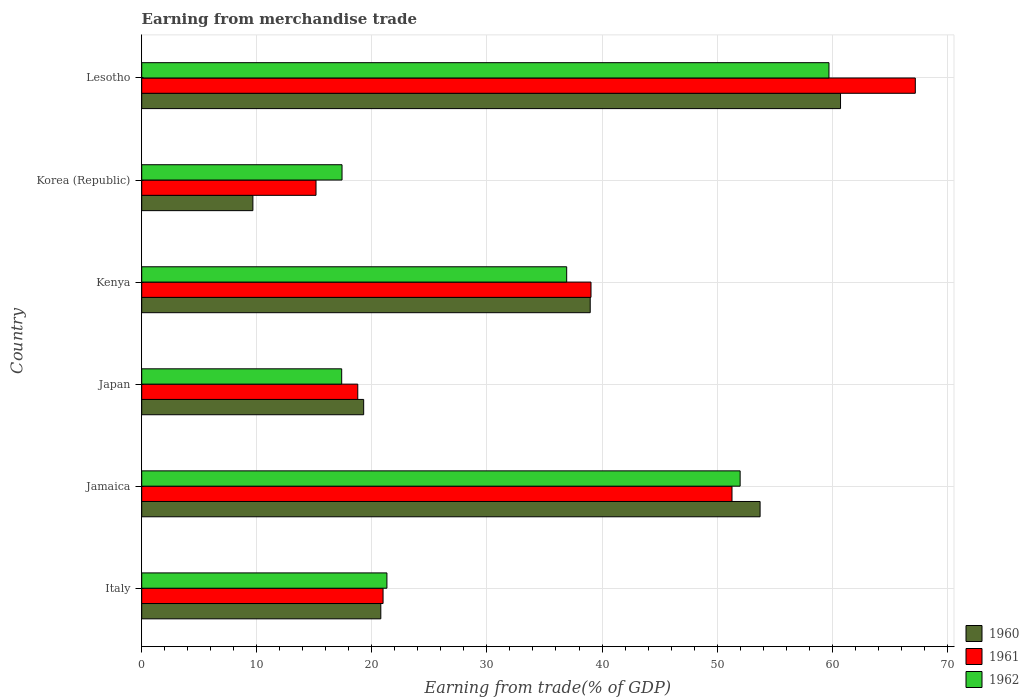How many groups of bars are there?
Give a very brief answer. 6. Are the number of bars per tick equal to the number of legend labels?
Your response must be concise. Yes. Are the number of bars on each tick of the Y-axis equal?
Keep it short and to the point. Yes. What is the label of the 4th group of bars from the top?
Give a very brief answer. Japan. What is the earnings from trade in 1960 in Japan?
Ensure brevity in your answer.  19.29. Across all countries, what is the maximum earnings from trade in 1962?
Provide a succinct answer. 59.72. Across all countries, what is the minimum earnings from trade in 1961?
Your answer should be compact. 15.15. In which country was the earnings from trade in 1961 maximum?
Provide a short and direct response. Lesotho. In which country was the earnings from trade in 1961 minimum?
Keep it short and to the point. Korea (Republic). What is the total earnings from trade in 1962 in the graph?
Offer a very short reply. 204.75. What is the difference between the earnings from trade in 1960 in Korea (Republic) and that in Lesotho?
Your answer should be very brief. -51.07. What is the difference between the earnings from trade in 1960 in Japan and the earnings from trade in 1962 in Jamaica?
Your response must be concise. -32.72. What is the average earnings from trade in 1961 per country?
Provide a succinct answer. 35.41. What is the difference between the earnings from trade in 1960 and earnings from trade in 1962 in Kenya?
Provide a short and direct response. 2.04. In how many countries, is the earnings from trade in 1961 greater than 48 %?
Provide a succinct answer. 2. What is the ratio of the earnings from trade in 1962 in Jamaica to that in Lesotho?
Your response must be concise. 0.87. What is the difference between the highest and the second highest earnings from trade in 1962?
Your answer should be compact. 7.72. What is the difference between the highest and the lowest earnings from trade in 1960?
Your answer should be compact. 51.07. Is the sum of the earnings from trade in 1960 in Jamaica and Japan greater than the maximum earnings from trade in 1962 across all countries?
Provide a succinct answer. Yes. What does the 1st bar from the top in Japan represents?
Keep it short and to the point. 1962. What does the 3rd bar from the bottom in Jamaica represents?
Give a very brief answer. 1962. Is it the case that in every country, the sum of the earnings from trade in 1960 and earnings from trade in 1962 is greater than the earnings from trade in 1961?
Make the answer very short. Yes. What is the difference between two consecutive major ticks on the X-axis?
Give a very brief answer. 10. Does the graph contain any zero values?
Give a very brief answer. No. Does the graph contain grids?
Ensure brevity in your answer.  Yes. Where does the legend appear in the graph?
Offer a terse response. Bottom right. How are the legend labels stacked?
Make the answer very short. Vertical. What is the title of the graph?
Offer a very short reply. Earning from merchandise trade. Does "2013" appear as one of the legend labels in the graph?
Provide a short and direct response. No. What is the label or title of the X-axis?
Give a very brief answer. Earning from trade(% of GDP). What is the label or title of the Y-axis?
Make the answer very short. Country. What is the Earning from trade(% of GDP) of 1960 in Italy?
Ensure brevity in your answer.  20.78. What is the Earning from trade(% of GDP) in 1961 in Italy?
Provide a short and direct response. 20.97. What is the Earning from trade(% of GDP) in 1962 in Italy?
Your answer should be compact. 21.31. What is the Earning from trade(% of GDP) of 1960 in Jamaica?
Provide a succinct answer. 53.74. What is the Earning from trade(% of GDP) of 1961 in Jamaica?
Provide a succinct answer. 51.3. What is the Earning from trade(% of GDP) of 1962 in Jamaica?
Your answer should be compact. 52. What is the Earning from trade(% of GDP) in 1960 in Japan?
Your answer should be very brief. 19.29. What is the Earning from trade(% of GDP) in 1961 in Japan?
Ensure brevity in your answer.  18.77. What is the Earning from trade(% of GDP) of 1962 in Japan?
Give a very brief answer. 17.38. What is the Earning from trade(% of GDP) of 1960 in Kenya?
Make the answer very short. 38.98. What is the Earning from trade(% of GDP) of 1961 in Kenya?
Provide a short and direct response. 39.04. What is the Earning from trade(% of GDP) of 1962 in Kenya?
Provide a succinct answer. 36.93. What is the Earning from trade(% of GDP) of 1960 in Korea (Republic)?
Offer a very short reply. 9.66. What is the Earning from trade(% of GDP) of 1961 in Korea (Republic)?
Provide a short and direct response. 15.15. What is the Earning from trade(% of GDP) of 1962 in Korea (Republic)?
Give a very brief answer. 17.41. What is the Earning from trade(% of GDP) in 1960 in Lesotho?
Offer a terse response. 60.73. What is the Earning from trade(% of GDP) in 1961 in Lesotho?
Offer a very short reply. 67.23. What is the Earning from trade(% of GDP) in 1962 in Lesotho?
Give a very brief answer. 59.72. Across all countries, what is the maximum Earning from trade(% of GDP) of 1960?
Your response must be concise. 60.73. Across all countries, what is the maximum Earning from trade(% of GDP) of 1961?
Provide a short and direct response. 67.23. Across all countries, what is the maximum Earning from trade(% of GDP) in 1962?
Your answer should be compact. 59.72. Across all countries, what is the minimum Earning from trade(% of GDP) of 1960?
Provide a succinct answer. 9.66. Across all countries, what is the minimum Earning from trade(% of GDP) of 1961?
Offer a terse response. 15.15. Across all countries, what is the minimum Earning from trade(% of GDP) of 1962?
Keep it short and to the point. 17.38. What is the total Earning from trade(% of GDP) of 1960 in the graph?
Provide a short and direct response. 203.17. What is the total Earning from trade(% of GDP) in 1961 in the graph?
Keep it short and to the point. 212.46. What is the total Earning from trade(% of GDP) in 1962 in the graph?
Provide a succinct answer. 204.75. What is the difference between the Earning from trade(% of GDP) of 1960 in Italy and that in Jamaica?
Provide a short and direct response. -32.96. What is the difference between the Earning from trade(% of GDP) in 1961 in Italy and that in Jamaica?
Your answer should be compact. -30.32. What is the difference between the Earning from trade(% of GDP) of 1962 in Italy and that in Jamaica?
Offer a terse response. -30.7. What is the difference between the Earning from trade(% of GDP) of 1960 in Italy and that in Japan?
Make the answer very short. 1.49. What is the difference between the Earning from trade(% of GDP) of 1961 in Italy and that in Japan?
Offer a terse response. 2.2. What is the difference between the Earning from trade(% of GDP) of 1962 in Italy and that in Japan?
Provide a short and direct response. 3.93. What is the difference between the Earning from trade(% of GDP) in 1960 in Italy and that in Kenya?
Offer a terse response. -18.2. What is the difference between the Earning from trade(% of GDP) in 1961 in Italy and that in Kenya?
Ensure brevity in your answer.  -18.07. What is the difference between the Earning from trade(% of GDP) in 1962 in Italy and that in Kenya?
Provide a short and direct response. -15.62. What is the difference between the Earning from trade(% of GDP) in 1960 in Italy and that in Korea (Republic)?
Offer a very short reply. 11.12. What is the difference between the Earning from trade(% of GDP) in 1961 in Italy and that in Korea (Republic)?
Provide a succinct answer. 5.83. What is the difference between the Earning from trade(% of GDP) in 1962 in Italy and that in Korea (Republic)?
Ensure brevity in your answer.  3.9. What is the difference between the Earning from trade(% of GDP) in 1960 in Italy and that in Lesotho?
Your answer should be very brief. -39.95. What is the difference between the Earning from trade(% of GDP) in 1961 in Italy and that in Lesotho?
Keep it short and to the point. -46.25. What is the difference between the Earning from trade(% of GDP) of 1962 in Italy and that in Lesotho?
Your answer should be very brief. -38.41. What is the difference between the Earning from trade(% of GDP) in 1960 in Jamaica and that in Japan?
Provide a succinct answer. 34.45. What is the difference between the Earning from trade(% of GDP) in 1961 in Jamaica and that in Japan?
Make the answer very short. 32.52. What is the difference between the Earning from trade(% of GDP) of 1962 in Jamaica and that in Japan?
Provide a succinct answer. 34.63. What is the difference between the Earning from trade(% of GDP) of 1960 in Jamaica and that in Kenya?
Your answer should be compact. 14.76. What is the difference between the Earning from trade(% of GDP) in 1961 in Jamaica and that in Kenya?
Offer a very short reply. 12.25. What is the difference between the Earning from trade(% of GDP) of 1962 in Jamaica and that in Kenya?
Offer a very short reply. 15.07. What is the difference between the Earning from trade(% of GDP) of 1960 in Jamaica and that in Korea (Republic)?
Keep it short and to the point. 44.08. What is the difference between the Earning from trade(% of GDP) in 1961 in Jamaica and that in Korea (Republic)?
Your answer should be compact. 36.15. What is the difference between the Earning from trade(% of GDP) of 1962 in Jamaica and that in Korea (Republic)?
Provide a succinct answer. 34.6. What is the difference between the Earning from trade(% of GDP) of 1960 in Jamaica and that in Lesotho?
Keep it short and to the point. -6.99. What is the difference between the Earning from trade(% of GDP) of 1961 in Jamaica and that in Lesotho?
Provide a succinct answer. -15.93. What is the difference between the Earning from trade(% of GDP) in 1962 in Jamaica and that in Lesotho?
Your answer should be compact. -7.72. What is the difference between the Earning from trade(% of GDP) in 1960 in Japan and that in Kenya?
Ensure brevity in your answer.  -19.69. What is the difference between the Earning from trade(% of GDP) in 1961 in Japan and that in Kenya?
Offer a very short reply. -20.27. What is the difference between the Earning from trade(% of GDP) of 1962 in Japan and that in Kenya?
Give a very brief answer. -19.55. What is the difference between the Earning from trade(% of GDP) of 1960 in Japan and that in Korea (Republic)?
Your response must be concise. 9.63. What is the difference between the Earning from trade(% of GDP) of 1961 in Japan and that in Korea (Republic)?
Your answer should be very brief. 3.63. What is the difference between the Earning from trade(% of GDP) of 1962 in Japan and that in Korea (Republic)?
Provide a short and direct response. -0.03. What is the difference between the Earning from trade(% of GDP) of 1960 in Japan and that in Lesotho?
Provide a succinct answer. -41.44. What is the difference between the Earning from trade(% of GDP) of 1961 in Japan and that in Lesotho?
Give a very brief answer. -48.45. What is the difference between the Earning from trade(% of GDP) of 1962 in Japan and that in Lesotho?
Give a very brief answer. -42.34. What is the difference between the Earning from trade(% of GDP) of 1960 in Kenya and that in Korea (Republic)?
Ensure brevity in your answer.  29.31. What is the difference between the Earning from trade(% of GDP) in 1961 in Kenya and that in Korea (Republic)?
Keep it short and to the point. 23.9. What is the difference between the Earning from trade(% of GDP) of 1962 in Kenya and that in Korea (Republic)?
Your answer should be compact. 19.52. What is the difference between the Earning from trade(% of GDP) of 1960 in Kenya and that in Lesotho?
Provide a short and direct response. -21.75. What is the difference between the Earning from trade(% of GDP) of 1961 in Kenya and that in Lesotho?
Keep it short and to the point. -28.18. What is the difference between the Earning from trade(% of GDP) in 1962 in Kenya and that in Lesotho?
Ensure brevity in your answer.  -22.79. What is the difference between the Earning from trade(% of GDP) of 1960 in Korea (Republic) and that in Lesotho?
Your response must be concise. -51.07. What is the difference between the Earning from trade(% of GDP) in 1961 in Korea (Republic) and that in Lesotho?
Make the answer very short. -52.08. What is the difference between the Earning from trade(% of GDP) of 1962 in Korea (Republic) and that in Lesotho?
Keep it short and to the point. -42.32. What is the difference between the Earning from trade(% of GDP) of 1960 in Italy and the Earning from trade(% of GDP) of 1961 in Jamaica?
Keep it short and to the point. -30.52. What is the difference between the Earning from trade(% of GDP) in 1960 in Italy and the Earning from trade(% of GDP) in 1962 in Jamaica?
Offer a terse response. -31.23. What is the difference between the Earning from trade(% of GDP) in 1961 in Italy and the Earning from trade(% of GDP) in 1962 in Jamaica?
Provide a succinct answer. -31.03. What is the difference between the Earning from trade(% of GDP) in 1960 in Italy and the Earning from trade(% of GDP) in 1961 in Japan?
Your answer should be very brief. 2. What is the difference between the Earning from trade(% of GDP) of 1960 in Italy and the Earning from trade(% of GDP) of 1962 in Japan?
Your response must be concise. 3.4. What is the difference between the Earning from trade(% of GDP) of 1961 in Italy and the Earning from trade(% of GDP) of 1962 in Japan?
Give a very brief answer. 3.59. What is the difference between the Earning from trade(% of GDP) in 1960 in Italy and the Earning from trade(% of GDP) in 1961 in Kenya?
Ensure brevity in your answer.  -18.27. What is the difference between the Earning from trade(% of GDP) in 1960 in Italy and the Earning from trade(% of GDP) in 1962 in Kenya?
Keep it short and to the point. -16.15. What is the difference between the Earning from trade(% of GDP) in 1961 in Italy and the Earning from trade(% of GDP) in 1962 in Kenya?
Provide a short and direct response. -15.96. What is the difference between the Earning from trade(% of GDP) in 1960 in Italy and the Earning from trade(% of GDP) in 1961 in Korea (Republic)?
Provide a succinct answer. 5.63. What is the difference between the Earning from trade(% of GDP) in 1960 in Italy and the Earning from trade(% of GDP) in 1962 in Korea (Republic)?
Your answer should be compact. 3.37. What is the difference between the Earning from trade(% of GDP) in 1961 in Italy and the Earning from trade(% of GDP) in 1962 in Korea (Republic)?
Provide a short and direct response. 3.57. What is the difference between the Earning from trade(% of GDP) of 1960 in Italy and the Earning from trade(% of GDP) of 1961 in Lesotho?
Ensure brevity in your answer.  -46.45. What is the difference between the Earning from trade(% of GDP) in 1960 in Italy and the Earning from trade(% of GDP) in 1962 in Lesotho?
Ensure brevity in your answer.  -38.95. What is the difference between the Earning from trade(% of GDP) in 1961 in Italy and the Earning from trade(% of GDP) in 1962 in Lesotho?
Offer a terse response. -38.75. What is the difference between the Earning from trade(% of GDP) in 1960 in Jamaica and the Earning from trade(% of GDP) in 1961 in Japan?
Your answer should be very brief. 34.96. What is the difference between the Earning from trade(% of GDP) of 1960 in Jamaica and the Earning from trade(% of GDP) of 1962 in Japan?
Keep it short and to the point. 36.36. What is the difference between the Earning from trade(% of GDP) of 1961 in Jamaica and the Earning from trade(% of GDP) of 1962 in Japan?
Your response must be concise. 33.92. What is the difference between the Earning from trade(% of GDP) in 1960 in Jamaica and the Earning from trade(% of GDP) in 1961 in Kenya?
Your answer should be compact. 14.69. What is the difference between the Earning from trade(% of GDP) in 1960 in Jamaica and the Earning from trade(% of GDP) in 1962 in Kenya?
Provide a succinct answer. 16.81. What is the difference between the Earning from trade(% of GDP) in 1961 in Jamaica and the Earning from trade(% of GDP) in 1962 in Kenya?
Your response must be concise. 14.37. What is the difference between the Earning from trade(% of GDP) in 1960 in Jamaica and the Earning from trade(% of GDP) in 1961 in Korea (Republic)?
Your answer should be compact. 38.59. What is the difference between the Earning from trade(% of GDP) in 1960 in Jamaica and the Earning from trade(% of GDP) in 1962 in Korea (Republic)?
Offer a very short reply. 36.33. What is the difference between the Earning from trade(% of GDP) in 1961 in Jamaica and the Earning from trade(% of GDP) in 1962 in Korea (Republic)?
Your answer should be compact. 33.89. What is the difference between the Earning from trade(% of GDP) of 1960 in Jamaica and the Earning from trade(% of GDP) of 1961 in Lesotho?
Offer a terse response. -13.49. What is the difference between the Earning from trade(% of GDP) of 1960 in Jamaica and the Earning from trade(% of GDP) of 1962 in Lesotho?
Ensure brevity in your answer.  -5.99. What is the difference between the Earning from trade(% of GDP) in 1961 in Jamaica and the Earning from trade(% of GDP) in 1962 in Lesotho?
Your response must be concise. -8.43. What is the difference between the Earning from trade(% of GDP) of 1960 in Japan and the Earning from trade(% of GDP) of 1961 in Kenya?
Your answer should be compact. -19.76. What is the difference between the Earning from trade(% of GDP) of 1960 in Japan and the Earning from trade(% of GDP) of 1962 in Kenya?
Your response must be concise. -17.64. What is the difference between the Earning from trade(% of GDP) in 1961 in Japan and the Earning from trade(% of GDP) in 1962 in Kenya?
Make the answer very short. -18.16. What is the difference between the Earning from trade(% of GDP) of 1960 in Japan and the Earning from trade(% of GDP) of 1961 in Korea (Republic)?
Make the answer very short. 4.14. What is the difference between the Earning from trade(% of GDP) of 1960 in Japan and the Earning from trade(% of GDP) of 1962 in Korea (Republic)?
Your answer should be very brief. 1.88. What is the difference between the Earning from trade(% of GDP) in 1961 in Japan and the Earning from trade(% of GDP) in 1962 in Korea (Republic)?
Your answer should be compact. 1.37. What is the difference between the Earning from trade(% of GDP) of 1960 in Japan and the Earning from trade(% of GDP) of 1961 in Lesotho?
Provide a succinct answer. -47.94. What is the difference between the Earning from trade(% of GDP) in 1960 in Japan and the Earning from trade(% of GDP) in 1962 in Lesotho?
Your answer should be compact. -40.44. What is the difference between the Earning from trade(% of GDP) in 1961 in Japan and the Earning from trade(% of GDP) in 1962 in Lesotho?
Keep it short and to the point. -40.95. What is the difference between the Earning from trade(% of GDP) in 1960 in Kenya and the Earning from trade(% of GDP) in 1961 in Korea (Republic)?
Offer a very short reply. 23.83. What is the difference between the Earning from trade(% of GDP) of 1960 in Kenya and the Earning from trade(% of GDP) of 1962 in Korea (Republic)?
Give a very brief answer. 21.57. What is the difference between the Earning from trade(% of GDP) of 1961 in Kenya and the Earning from trade(% of GDP) of 1962 in Korea (Republic)?
Keep it short and to the point. 21.64. What is the difference between the Earning from trade(% of GDP) in 1960 in Kenya and the Earning from trade(% of GDP) in 1961 in Lesotho?
Keep it short and to the point. -28.25. What is the difference between the Earning from trade(% of GDP) in 1960 in Kenya and the Earning from trade(% of GDP) in 1962 in Lesotho?
Provide a short and direct response. -20.75. What is the difference between the Earning from trade(% of GDP) of 1961 in Kenya and the Earning from trade(% of GDP) of 1962 in Lesotho?
Ensure brevity in your answer.  -20.68. What is the difference between the Earning from trade(% of GDP) in 1960 in Korea (Republic) and the Earning from trade(% of GDP) in 1961 in Lesotho?
Offer a very short reply. -57.57. What is the difference between the Earning from trade(% of GDP) of 1960 in Korea (Republic) and the Earning from trade(% of GDP) of 1962 in Lesotho?
Your answer should be very brief. -50.06. What is the difference between the Earning from trade(% of GDP) of 1961 in Korea (Republic) and the Earning from trade(% of GDP) of 1962 in Lesotho?
Provide a short and direct response. -44.58. What is the average Earning from trade(% of GDP) in 1960 per country?
Offer a very short reply. 33.86. What is the average Earning from trade(% of GDP) of 1961 per country?
Keep it short and to the point. 35.41. What is the average Earning from trade(% of GDP) of 1962 per country?
Make the answer very short. 34.13. What is the difference between the Earning from trade(% of GDP) in 1960 and Earning from trade(% of GDP) in 1961 in Italy?
Keep it short and to the point. -0.2. What is the difference between the Earning from trade(% of GDP) in 1960 and Earning from trade(% of GDP) in 1962 in Italy?
Provide a succinct answer. -0.53. What is the difference between the Earning from trade(% of GDP) in 1961 and Earning from trade(% of GDP) in 1962 in Italy?
Give a very brief answer. -0.34. What is the difference between the Earning from trade(% of GDP) of 1960 and Earning from trade(% of GDP) of 1961 in Jamaica?
Offer a terse response. 2.44. What is the difference between the Earning from trade(% of GDP) in 1960 and Earning from trade(% of GDP) in 1962 in Jamaica?
Keep it short and to the point. 1.73. What is the difference between the Earning from trade(% of GDP) of 1961 and Earning from trade(% of GDP) of 1962 in Jamaica?
Your response must be concise. -0.71. What is the difference between the Earning from trade(% of GDP) in 1960 and Earning from trade(% of GDP) in 1961 in Japan?
Offer a very short reply. 0.51. What is the difference between the Earning from trade(% of GDP) of 1960 and Earning from trade(% of GDP) of 1962 in Japan?
Give a very brief answer. 1.91. What is the difference between the Earning from trade(% of GDP) in 1961 and Earning from trade(% of GDP) in 1962 in Japan?
Offer a terse response. 1.4. What is the difference between the Earning from trade(% of GDP) of 1960 and Earning from trade(% of GDP) of 1961 in Kenya?
Your response must be concise. -0.07. What is the difference between the Earning from trade(% of GDP) of 1960 and Earning from trade(% of GDP) of 1962 in Kenya?
Offer a terse response. 2.04. What is the difference between the Earning from trade(% of GDP) in 1961 and Earning from trade(% of GDP) in 1962 in Kenya?
Make the answer very short. 2.11. What is the difference between the Earning from trade(% of GDP) in 1960 and Earning from trade(% of GDP) in 1961 in Korea (Republic)?
Offer a terse response. -5.48. What is the difference between the Earning from trade(% of GDP) in 1960 and Earning from trade(% of GDP) in 1962 in Korea (Republic)?
Give a very brief answer. -7.75. What is the difference between the Earning from trade(% of GDP) of 1961 and Earning from trade(% of GDP) of 1962 in Korea (Republic)?
Offer a very short reply. -2.26. What is the difference between the Earning from trade(% of GDP) of 1960 and Earning from trade(% of GDP) of 1961 in Lesotho?
Your answer should be very brief. -6.5. What is the difference between the Earning from trade(% of GDP) of 1960 and Earning from trade(% of GDP) of 1962 in Lesotho?
Your answer should be very brief. 1.01. What is the difference between the Earning from trade(% of GDP) in 1961 and Earning from trade(% of GDP) in 1962 in Lesotho?
Make the answer very short. 7.5. What is the ratio of the Earning from trade(% of GDP) in 1960 in Italy to that in Jamaica?
Offer a terse response. 0.39. What is the ratio of the Earning from trade(% of GDP) in 1961 in Italy to that in Jamaica?
Make the answer very short. 0.41. What is the ratio of the Earning from trade(% of GDP) in 1962 in Italy to that in Jamaica?
Keep it short and to the point. 0.41. What is the ratio of the Earning from trade(% of GDP) of 1960 in Italy to that in Japan?
Offer a very short reply. 1.08. What is the ratio of the Earning from trade(% of GDP) of 1961 in Italy to that in Japan?
Make the answer very short. 1.12. What is the ratio of the Earning from trade(% of GDP) of 1962 in Italy to that in Japan?
Make the answer very short. 1.23. What is the ratio of the Earning from trade(% of GDP) in 1960 in Italy to that in Kenya?
Give a very brief answer. 0.53. What is the ratio of the Earning from trade(% of GDP) in 1961 in Italy to that in Kenya?
Provide a succinct answer. 0.54. What is the ratio of the Earning from trade(% of GDP) of 1962 in Italy to that in Kenya?
Provide a short and direct response. 0.58. What is the ratio of the Earning from trade(% of GDP) of 1960 in Italy to that in Korea (Republic)?
Ensure brevity in your answer.  2.15. What is the ratio of the Earning from trade(% of GDP) in 1961 in Italy to that in Korea (Republic)?
Give a very brief answer. 1.38. What is the ratio of the Earning from trade(% of GDP) of 1962 in Italy to that in Korea (Republic)?
Provide a short and direct response. 1.22. What is the ratio of the Earning from trade(% of GDP) in 1960 in Italy to that in Lesotho?
Offer a terse response. 0.34. What is the ratio of the Earning from trade(% of GDP) of 1961 in Italy to that in Lesotho?
Keep it short and to the point. 0.31. What is the ratio of the Earning from trade(% of GDP) in 1962 in Italy to that in Lesotho?
Keep it short and to the point. 0.36. What is the ratio of the Earning from trade(% of GDP) of 1960 in Jamaica to that in Japan?
Ensure brevity in your answer.  2.79. What is the ratio of the Earning from trade(% of GDP) in 1961 in Jamaica to that in Japan?
Give a very brief answer. 2.73. What is the ratio of the Earning from trade(% of GDP) of 1962 in Jamaica to that in Japan?
Provide a short and direct response. 2.99. What is the ratio of the Earning from trade(% of GDP) of 1960 in Jamaica to that in Kenya?
Ensure brevity in your answer.  1.38. What is the ratio of the Earning from trade(% of GDP) in 1961 in Jamaica to that in Kenya?
Provide a short and direct response. 1.31. What is the ratio of the Earning from trade(% of GDP) of 1962 in Jamaica to that in Kenya?
Provide a succinct answer. 1.41. What is the ratio of the Earning from trade(% of GDP) in 1960 in Jamaica to that in Korea (Republic)?
Your response must be concise. 5.56. What is the ratio of the Earning from trade(% of GDP) of 1961 in Jamaica to that in Korea (Republic)?
Ensure brevity in your answer.  3.39. What is the ratio of the Earning from trade(% of GDP) of 1962 in Jamaica to that in Korea (Republic)?
Give a very brief answer. 2.99. What is the ratio of the Earning from trade(% of GDP) in 1960 in Jamaica to that in Lesotho?
Give a very brief answer. 0.88. What is the ratio of the Earning from trade(% of GDP) of 1961 in Jamaica to that in Lesotho?
Your answer should be very brief. 0.76. What is the ratio of the Earning from trade(% of GDP) of 1962 in Jamaica to that in Lesotho?
Keep it short and to the point. 0.87. What is the ratio of the Earning from trade(% of GDP) of 1960 in Japan to that in Kenya?
Make the answer very short. 0.49. What is the ratio of the Earning from trade(% of GDP) in 1961 in Japan to that in Kenya?
Provide a succinct answer. 0.48. What is the ratio of the Earning from trade(% of GDP) in 1962 in Japan to that in Kenya?
Offer a terse response. 0.47. What is the ratio of the Earning from trade(% of GDP) of 1960 in Japan to that in Korea (Republic)?
Give a very brief answer. 2. What is the ratio of the Earning from trade(% of GDP) of 1961 in Japan to that in Korea (Republic)?
Keep it short and to the point. 1.24. What is the ratio of the Earning from trade(% of GDP) of 1962 in Japan to that in Korea (Republic)?
Provide a succinct answer. 1. What is the ratio of the Earning from trade(% of GDP) of 1960 in Japan to that in Lesotho?
Keep it short and to the point. 0.32. What is the ratio of the Earning from trade(% of GDP) of 1961 in Japan to that in Lesotho?
Make the answer very short. 0.28. What is the ratio of the Earning from trade(% of GDP) in 1962 in Japan to that in Lesotho?
Ensure brevity in your answer.  0.29. What is the ratio of the Earning from trade(% of GDP) in 1960 in Kenya to that in Korea (Republic)?
Provide a succinct answer. 4.03. What is the ratio of the Earning from trade(% of GDP) in 1961 in Kenya to that in Korea (Republic)?
Make the answer very short. 2.58. What is the ratio of the Earning from trade(% of GDP) in 1962 in Kenya to that in Korea (Republic)?
Provide a short and direct response. 2.12. What is the ratio of the Earning from trade(% of GDP) of 1960 in Kenya to that in Lesotho?
Your response must be concise. 0.64. What is the ratio of the Earning from trade(% of GDP) of 1961 in Kenya to that in Lesotho?
Keep it short and to the point. 0.58. What is the ratio of the Earning from trade(% of GDP) in 1962 in Kenya to that in Lesotho?
Provide a short and direct response. 0.62. What is the ratio of the Earning from trade(% of GDP) in 1960 in Korea (Republic) to that in Lesotho?
Ensure brevity in your answer.  0.16. What is the ratio of the Earning from trade(% of GDP) of 1961 in Korea (Republic) to that in Lesotho?
Provide a short and direct response. 0.23. What is the ratio of the Earning from trade(% of GDP) in 1962 in Korea (Republic) to that in Lesotho?
Provide a short and direct response. 0.29. What is the difference between the highest and the second highest Earning from trade(% of GDP) in 1960?
Provide a short and direct response. 6.99. What is the difference between the highest and the second highest Earning from trade(% of GDP) in 1961?
Ensure brevity in your answer.  15.93. What is the difference between the highest and the second highest Earning from trade(% of GDP) in 1962?
Offer a very short reply. 7.72. What is the difference between the highest and the lowest Earning from trade(% of GDP) in 1960?
Make the answer very short. 51.07. What is the difference between the highest and the lowest Earning from trade(% of GDP) of 1961?
Offer a very short reply. 52.08. What is the difference between the highest and the lowest Earning from trade(% of GDP) of 1962?
Make the answer very short. 42.34. 